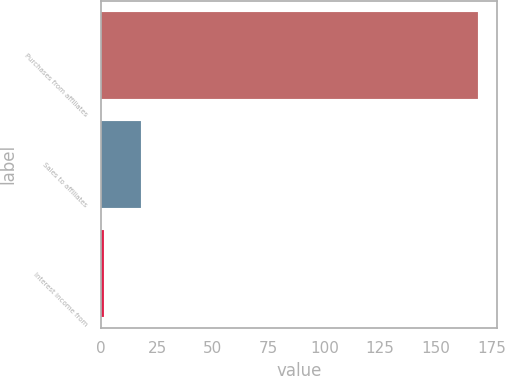Convert chart to OTSL. <chart><loc_0><loc_0><loc_500><loc_500><bar_chart><fcel>Purchases from affiliates<fcel>Sales to affiliates<fcel>Interest income from<nl><fcel>169<fcel>17.8<fcel>1<nl></chart> 